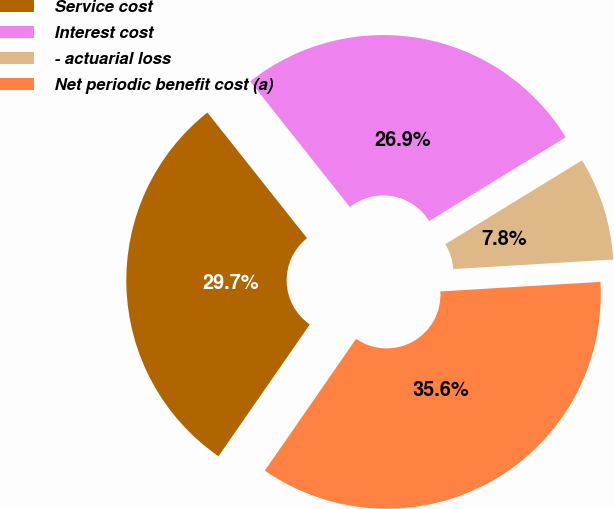<chart> <loc_0><loc_0><loc_500><loc_500><pie_chart><fcel>Service cost<fcel>Interest cost<fcel>- actuarial loss<fcel>Net periodic benefit cost (a)<nl><fcel>29.69%<fcel>26.91%<fcel>7.81%<fcel>35.59%<nl></chart> 